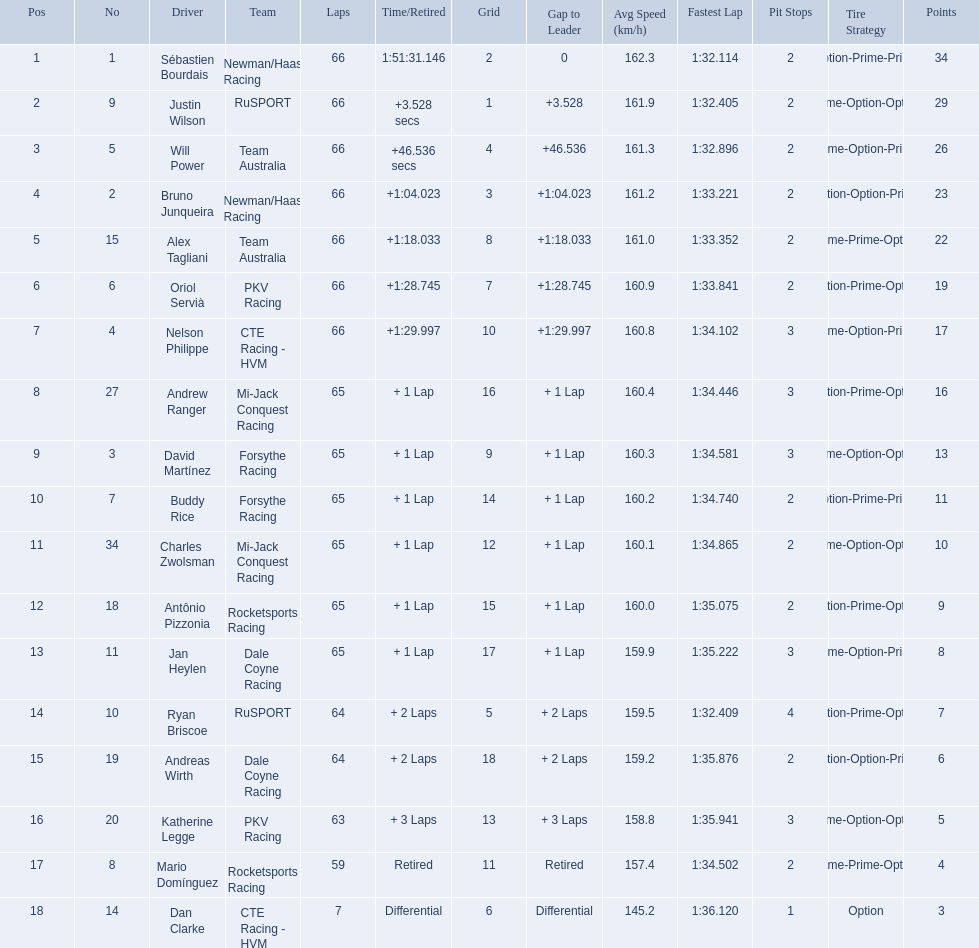What was the highest amount of points scored in the 2006 gran premio? 34. Who scored 34 points? Sébastien Bourdais. 